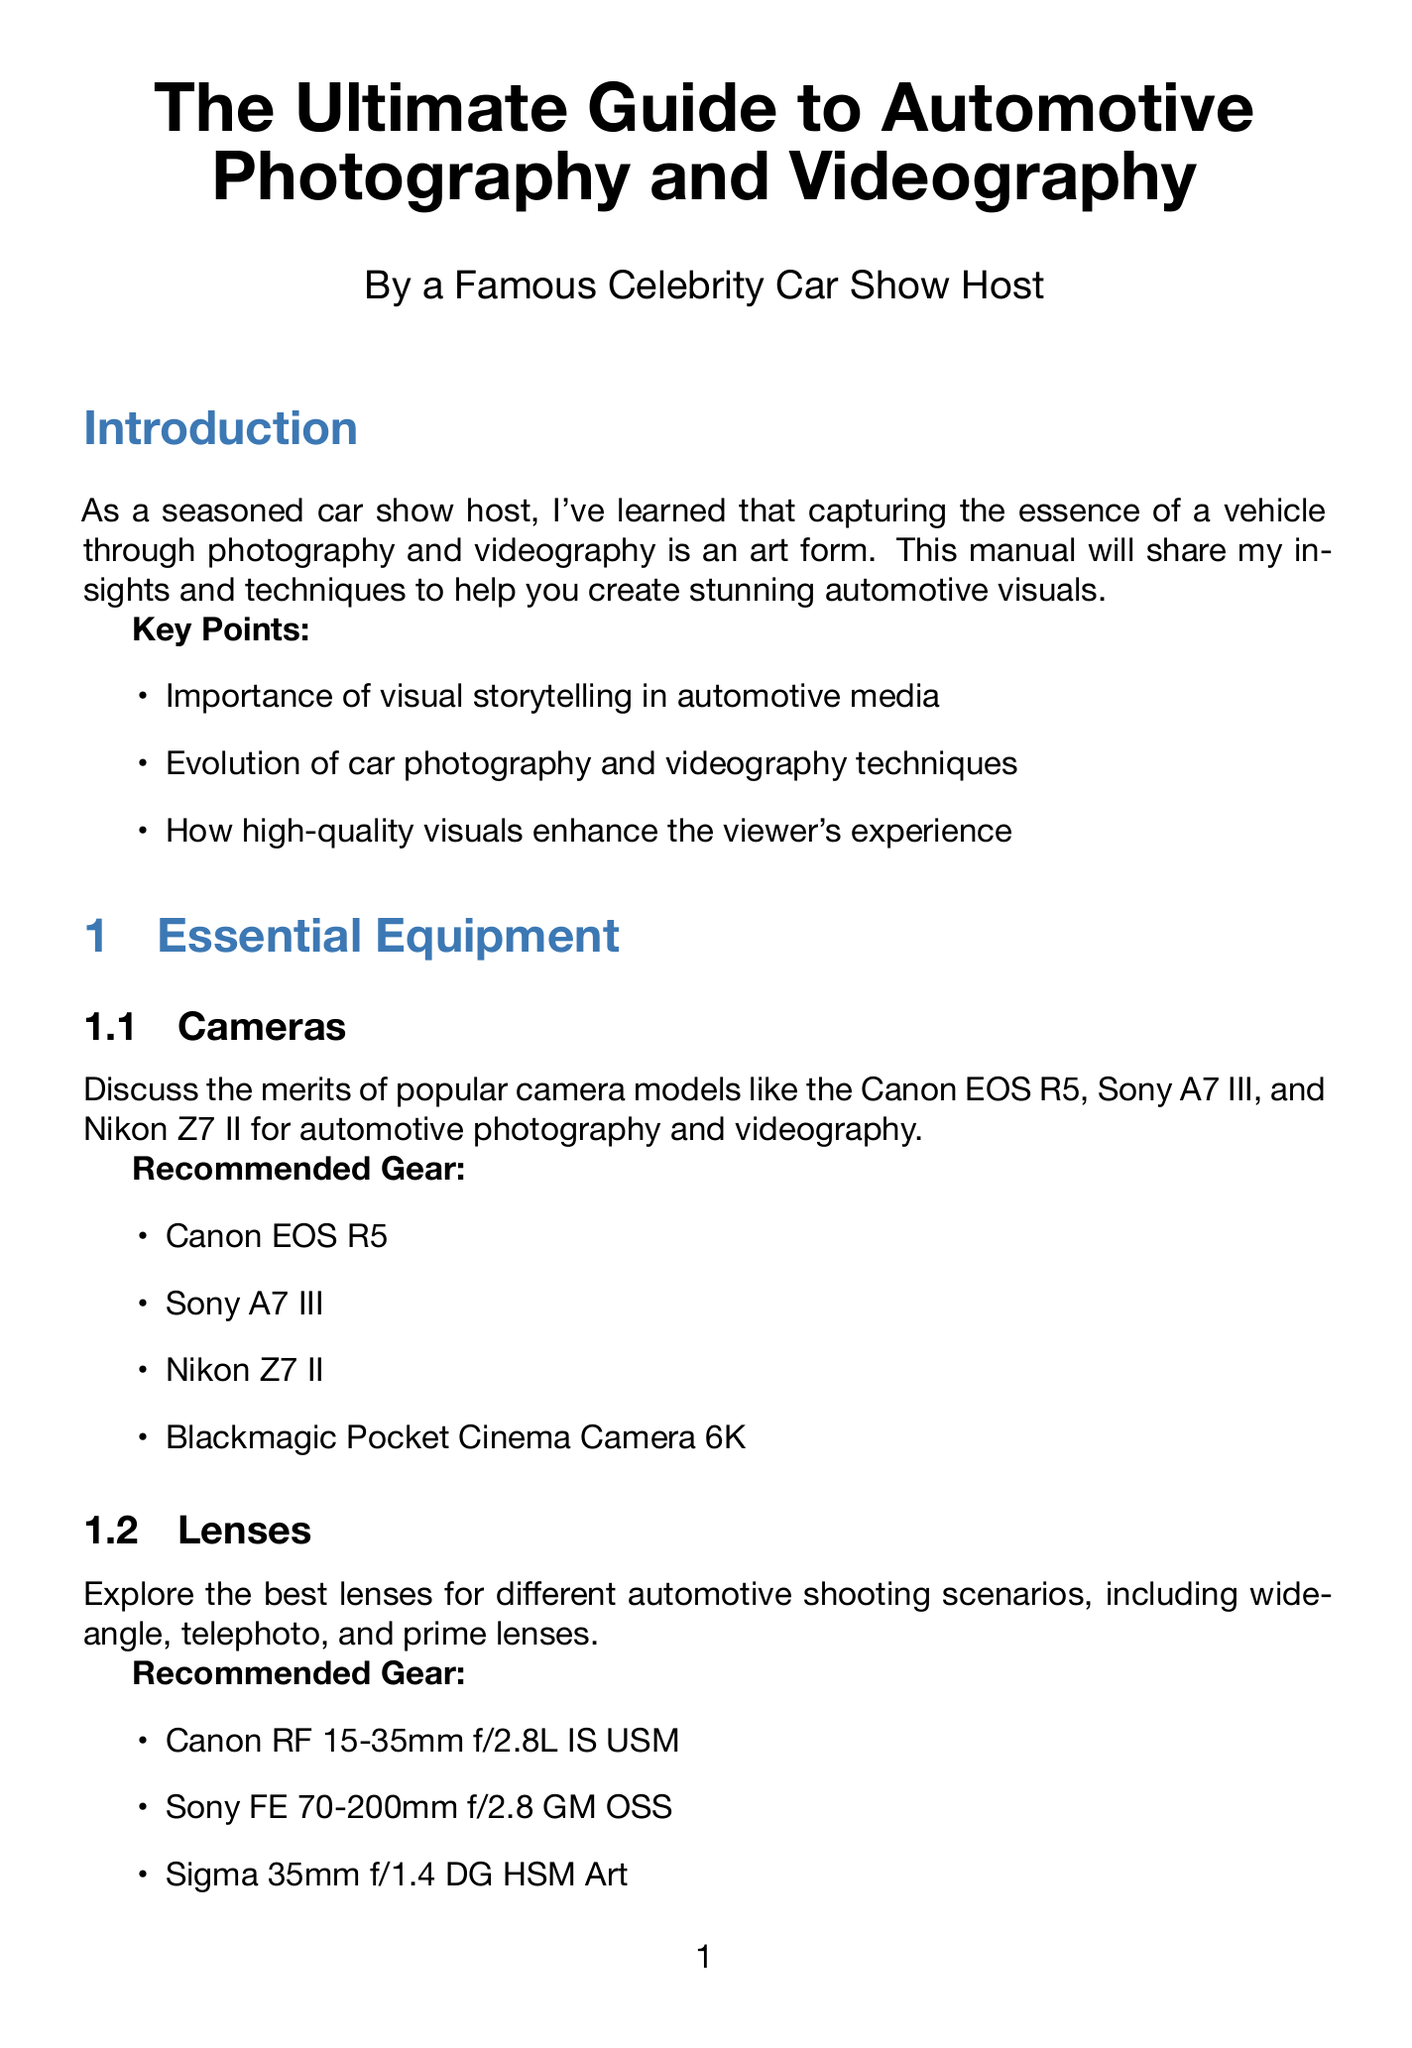What is the title of the manual? The title of the manual is specified in the document's header.
Answer: The Ultimate Guide to Automotive Photography and Videography Who is the author of the manual? The author is mentioned in the title section of the document.
Answer: A Famous Celebrity Car Show Host What is the first recommended camera? The first camera is listed in the recommended gear section for cameras.
Answer: Canon EOS R5 What is the key setting for panning shots? The key settings for panning shots are provided in the relevant section.
Answer: Shutter speed: 1/15 to 1/60 second What lighting technique is recommended for overcast days? The technique discussed in the natural light section covers using overcast days.
Answer: Use polarizing filters to manage reflections What is the main focus of the conclusion? The conclusion summarizes the main takeaway of the document.
Answer: Create automotive visuals that captivate audiences How many chapters are in the document? The number of chapters is indicated in the structure of the manual.
Answer: Six chapters What is the importance of storyboarding in video? The video storytelling section explains storyboarding's significance.
Answer: Creating compelling automotive video content What is one of the final tips provided in the conclusion? The final tips section provides several conclusions.
Answer: Always prioritize safety during shoots 